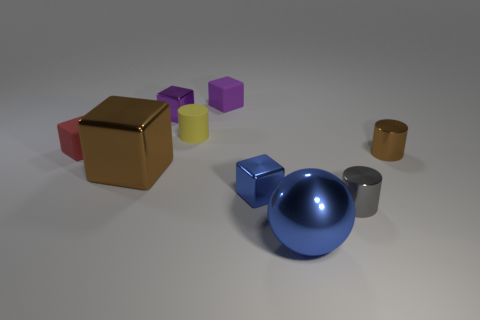Subtract all green cubes. Subtract all blue balls. How many cubes are left? 5 Subtract all cubes. How many objects are left? 4 Add 1 big cyan balls. How many big cyan balls exist? 1 Subtract 1 yellow cylinders. How many objects are left? 8 Subtract all shiny cylinders. Subtract all small yellow rubber things. How many objects are left? 6 Add 5 metal balls. How many metal balls are left? 6 